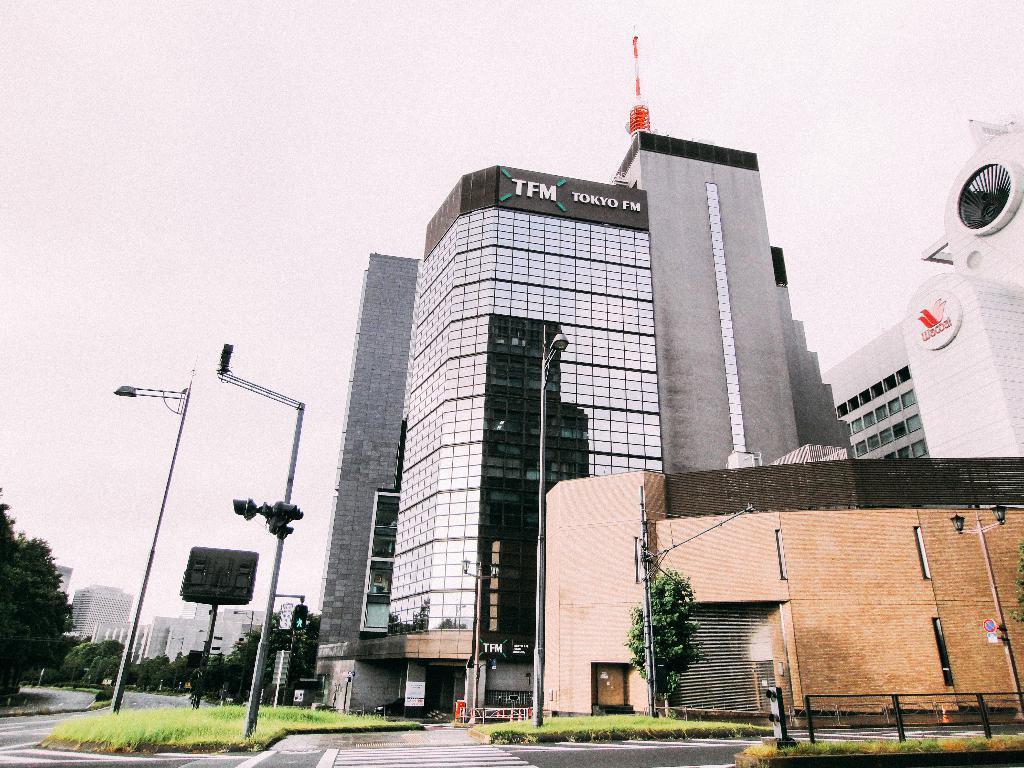Describe this image in one or two sentences. Here we can see buildings with glass windows. Here we can see light poles, trees and grass. 